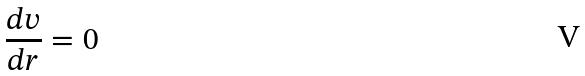Convert formula to latex. <formula><loc_0><loc_0><loc_500><loc_500>\frac { d v } { d r } = 0</formula> 